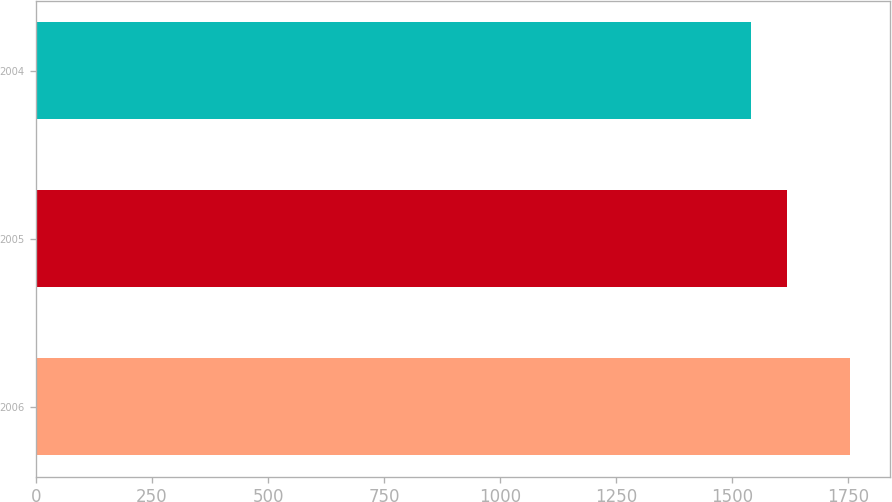Convert chart. <chart><loc_0><loc_0><loc_500><loc_500><bar_chart><fcel>2006<fcel>2005<fcel>2004<nl><fcel>1752.9<fcel>1617.9<fcel>1541.3<nl></chart> 